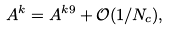<formula> <loc_0><loc_0><loc_500><loc_500>A ^ { k } = A ^ { k 9 } + \mathcal { O } ( 1 / N _ { c } ) ,</formula> 